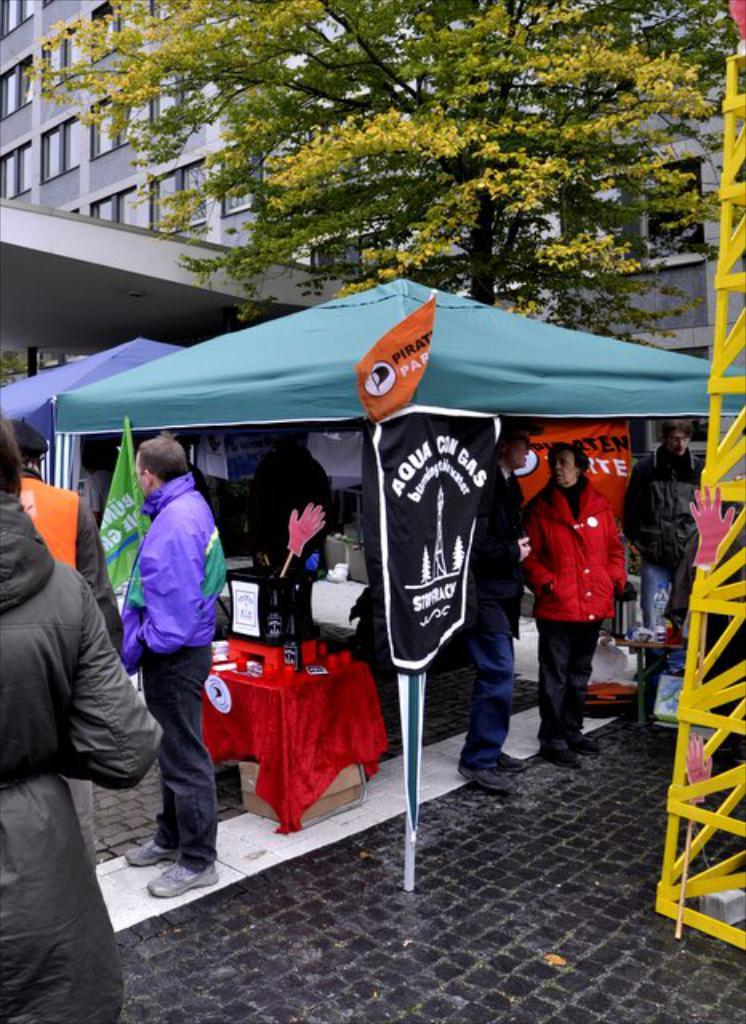How many people can be seen in the image? There are many people standing on the ground in the image. What structures are visible in the front of the image? There are tents in the front of the image. What can be seen in the background of the image? There is a building and a tree in the background of the image. What is located to the right of the image? There is a stand to the right of the image. How many donkeys are grazing in the sand in the image? There are no donkeys or sand present in the image. What type of flock can be seen flying over the tree in the image? There is no flock of any kind visible in the image. 